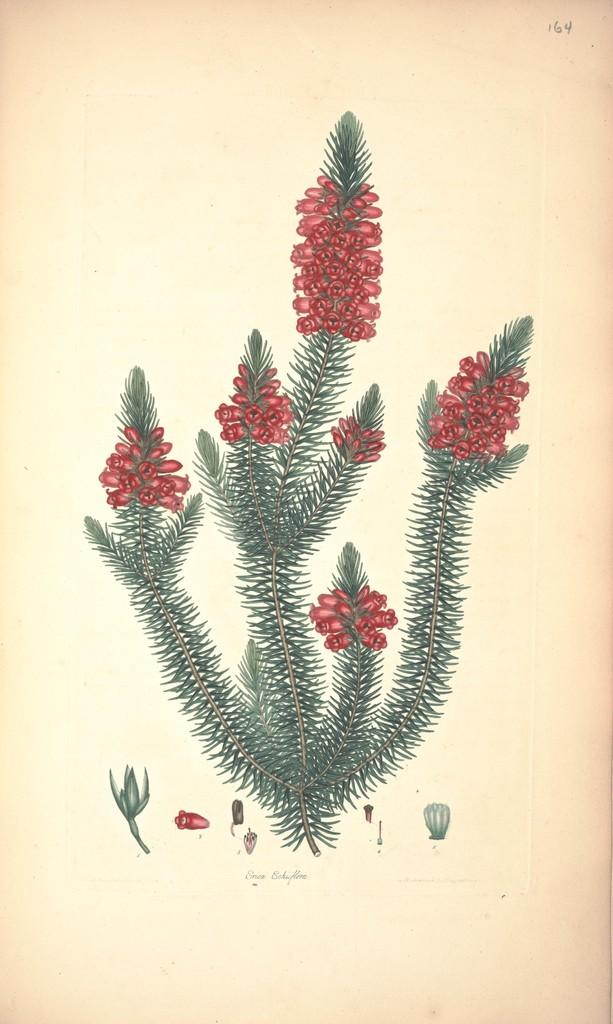What is featured in the image? There is a poster in the image. What is depicted on the poster? The poster contains an art of a plant. What can be observed about the plant in the image? The plant has red flowers. What type of card is the carpenter using to cut the vegetable in the image? There is no card, carpenter, or vegetable present in the image. The image only features a poster with an art of a plant. 